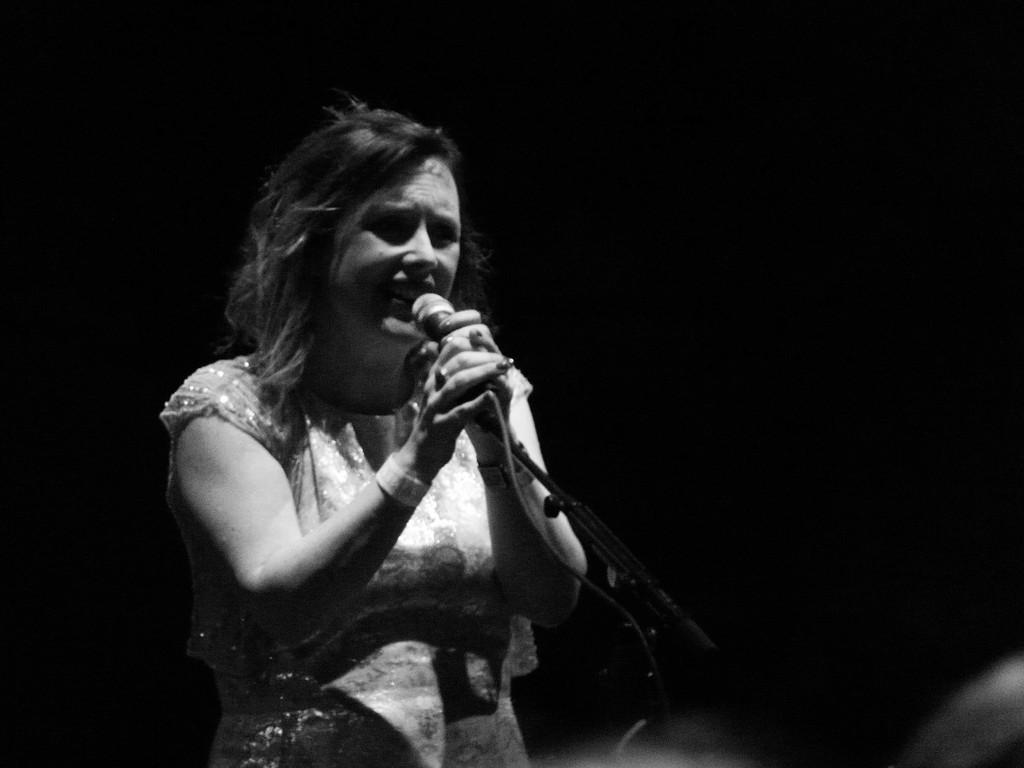What is the main subject of the image? There is a person in the image. What is the person doing in the image? The person is standing and singing. What object is the person holding in the image? The person is holding a microphone. What is the color scheme of the image? The image is in black and white. How many cherries are on the person's head in the image? There are no cherries present on the person's head in the image. What type of care does the person need in the image? The image does not depict any need for care; it shows a person singing with a microphone. 